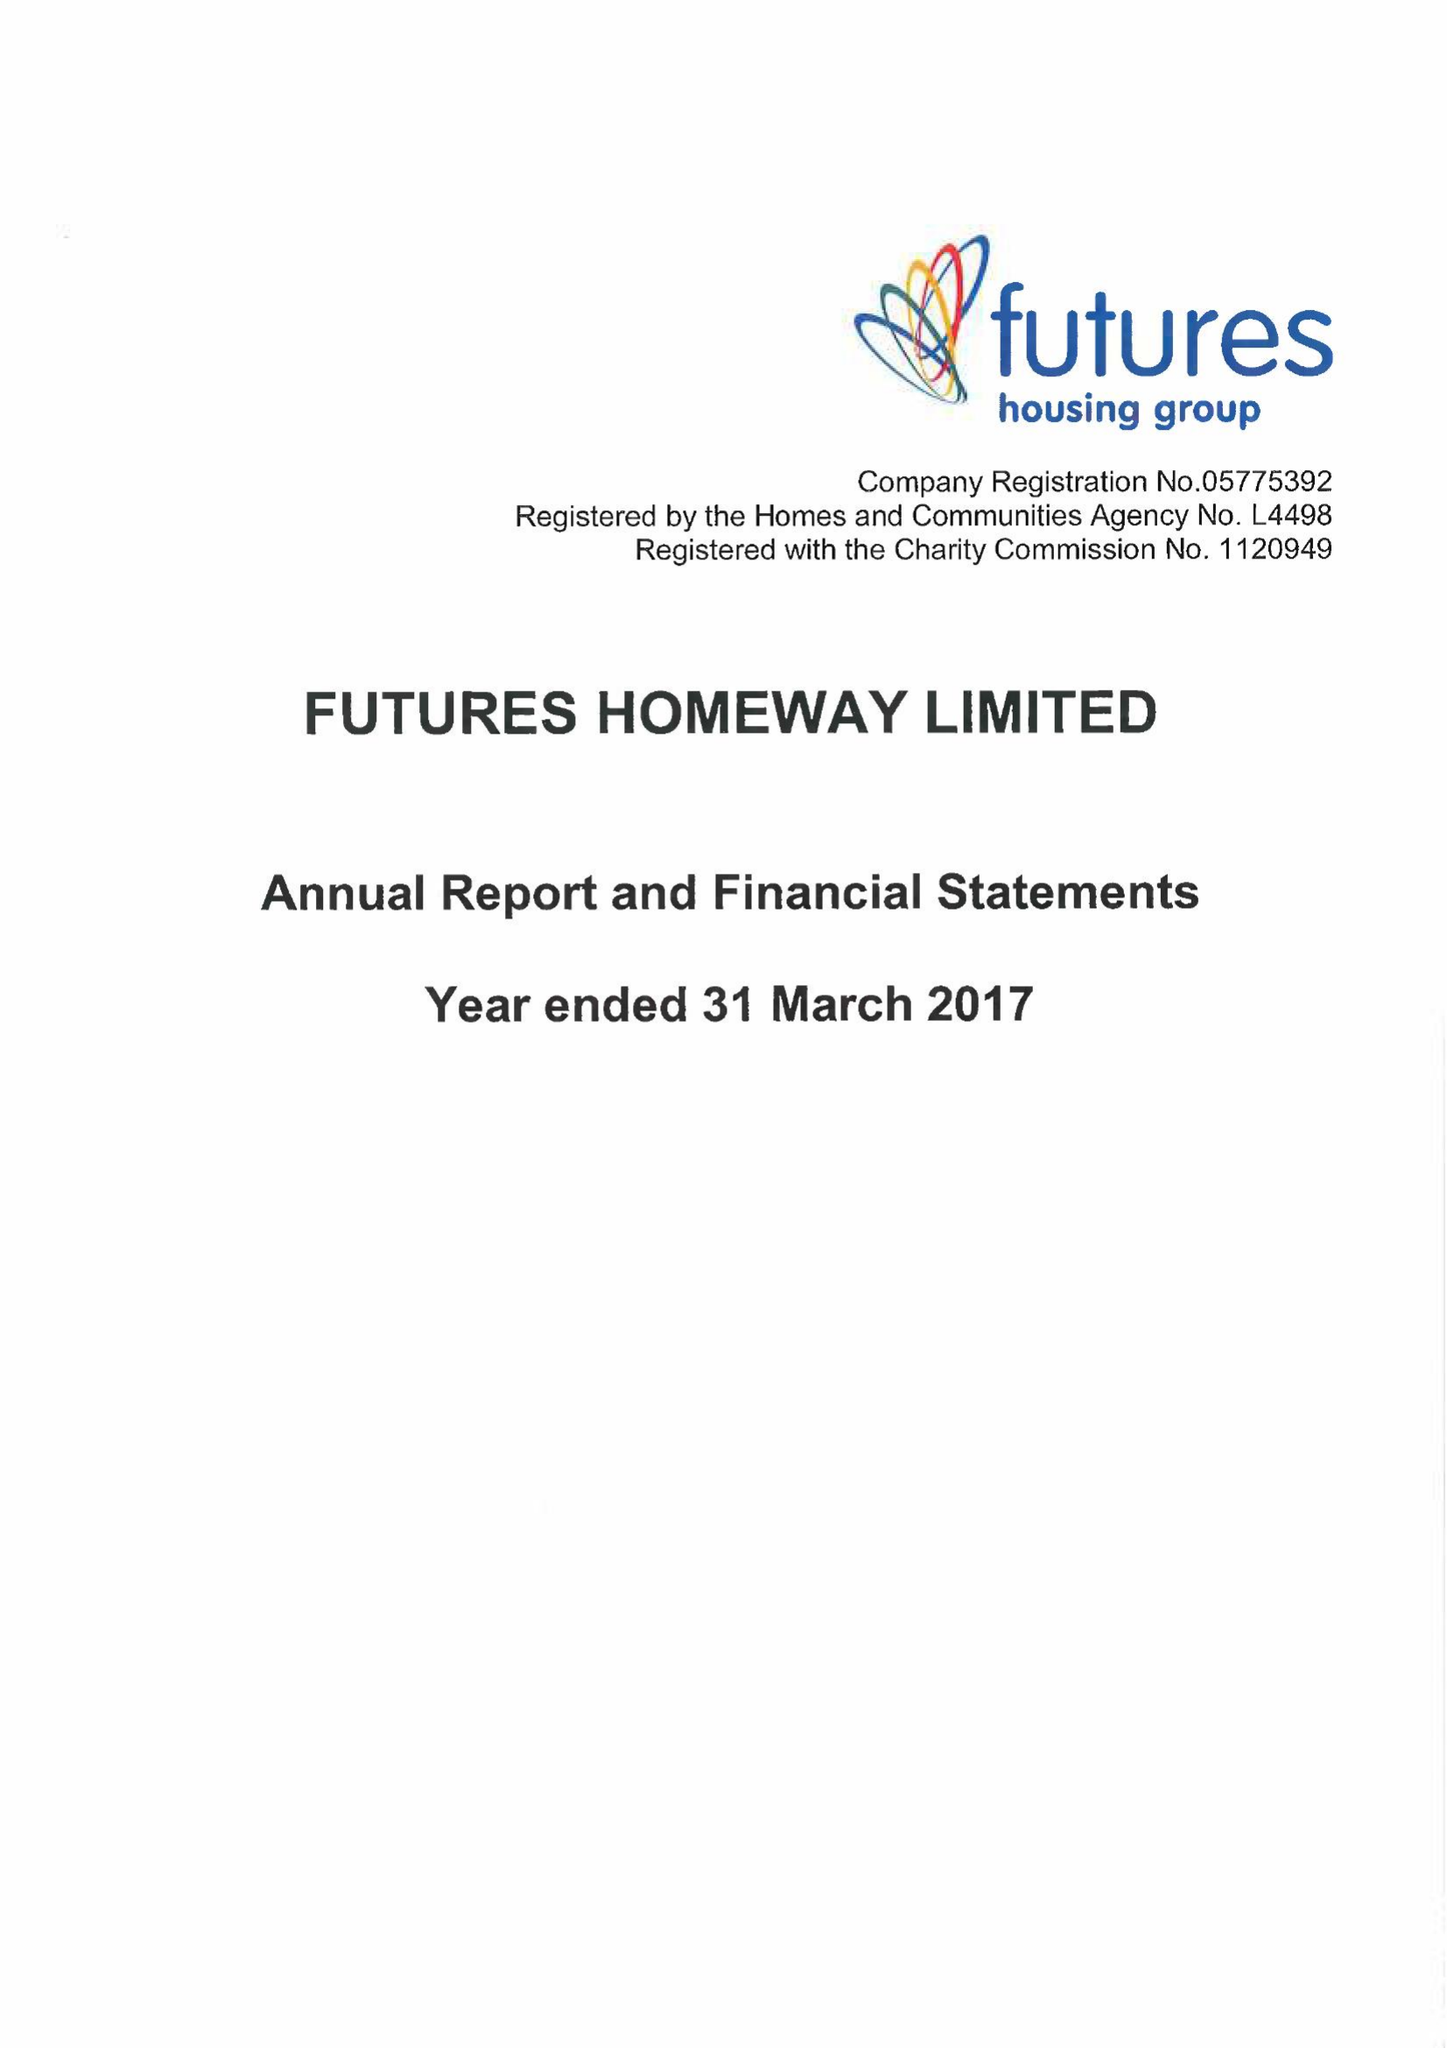What is the value for the charity_name?
Answer the question using a single word or phrase. Futures Homeway Ltd. 